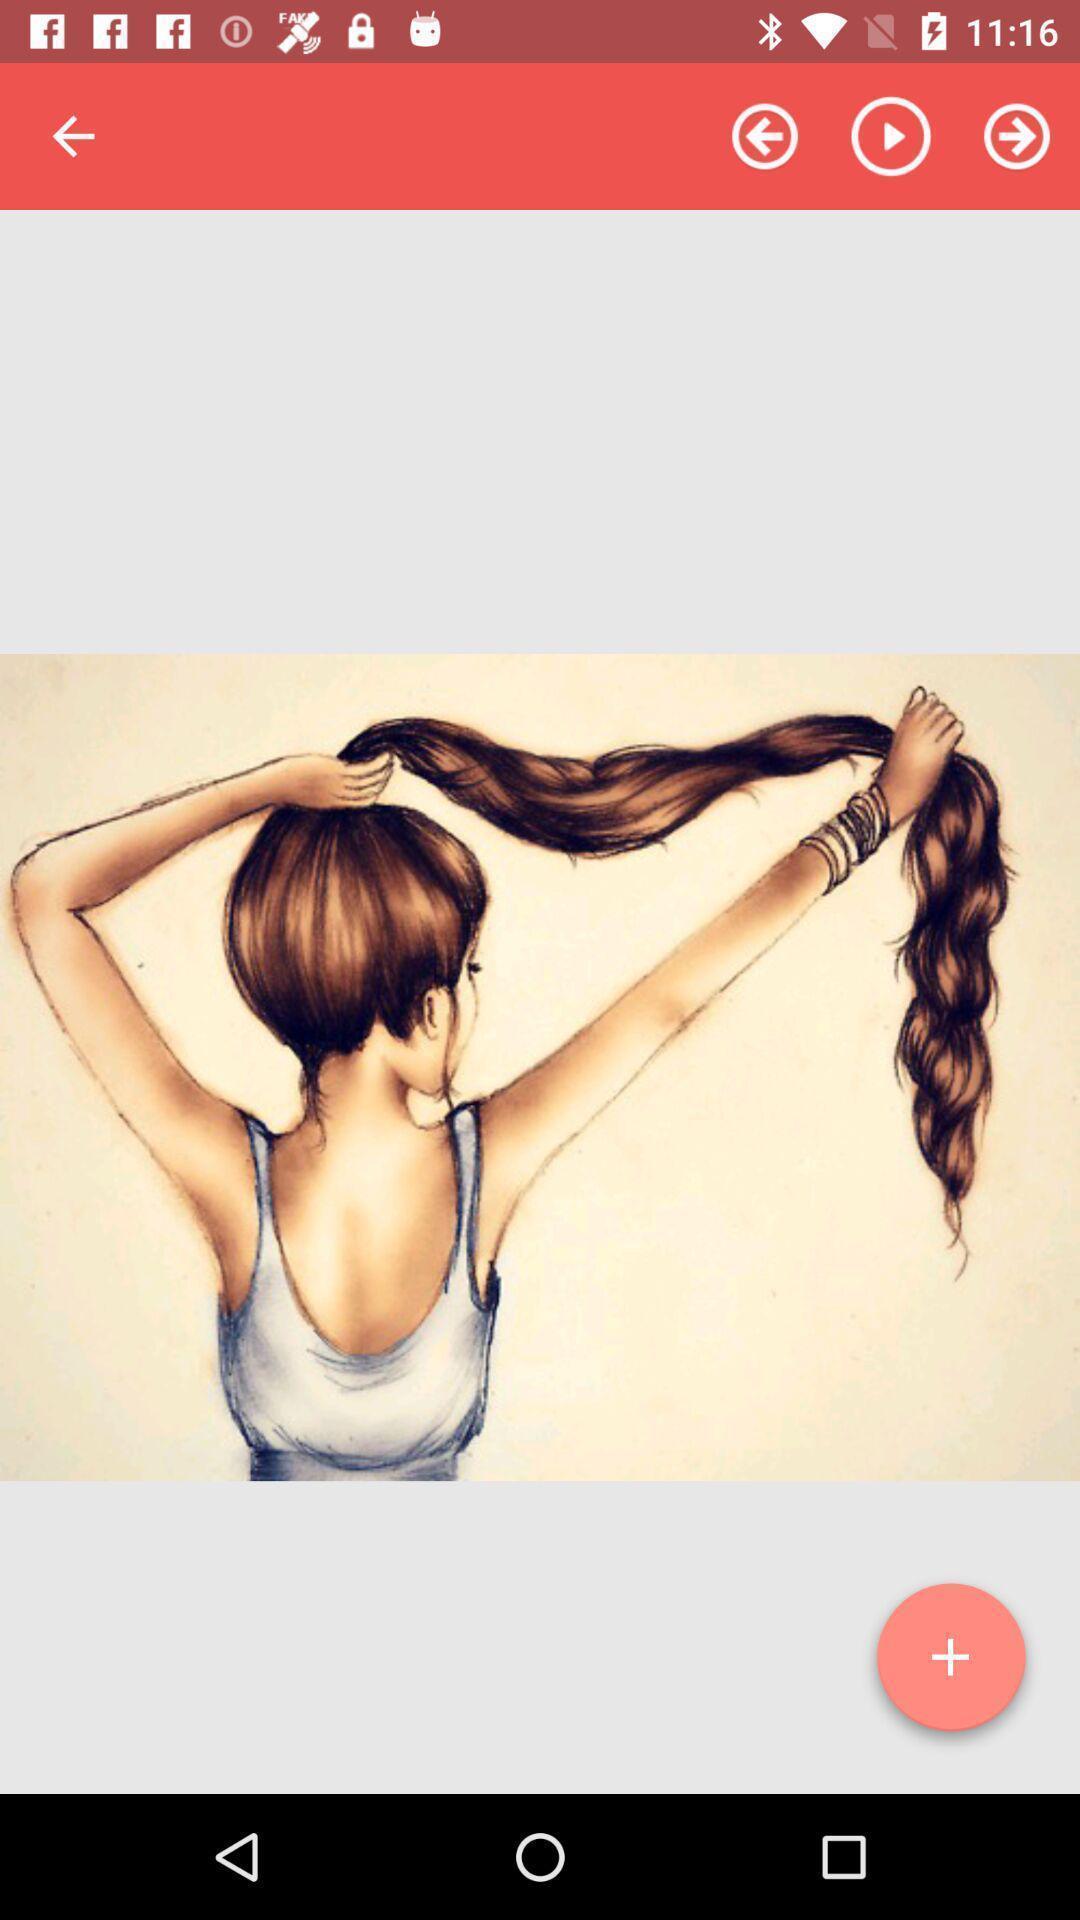Explain the elements present in this screenshot. Page that displaying image. 